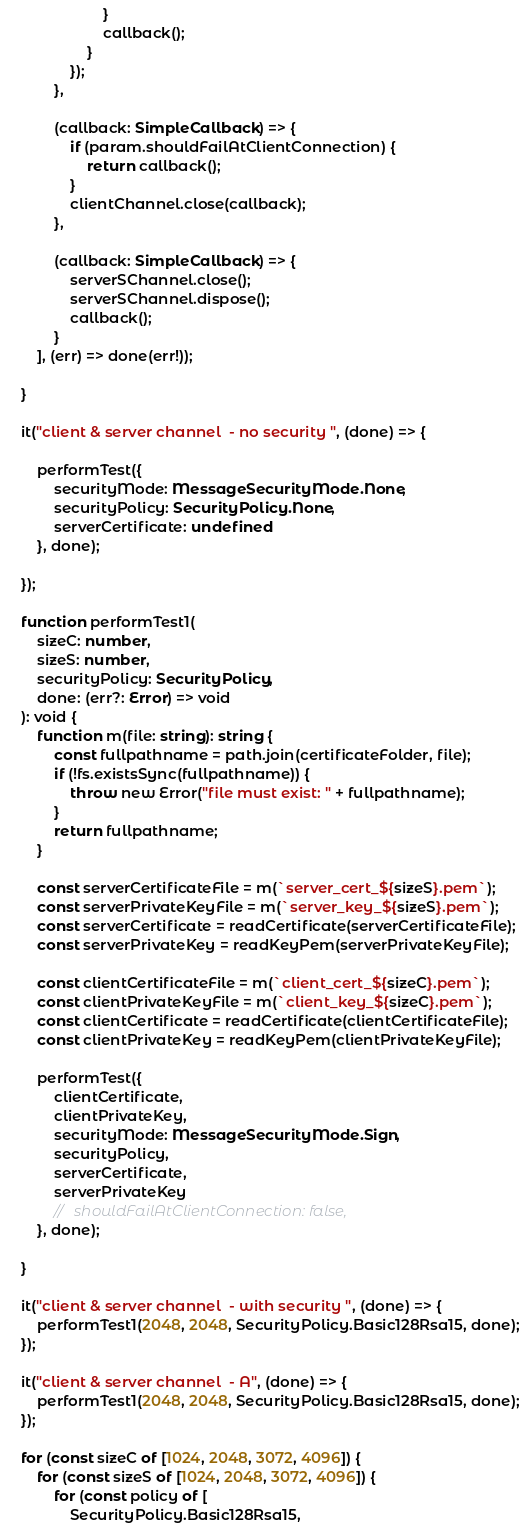Convert code to text. <code><loc_0><loc_0><loc_500><loc_500><_TypeScript_>                        }
                        callback();
                    }
                });
            },

            (callback: SimpleCallback) => {
                if (param.shouldFailAtClientConnection) {
                    return callback();
                }
                clientChannel.close(callback);
            },

            (callback: SimpleCallback) => {
                serverSChannel.close();
                serverSChannel.dispose();
                callback();
            }
        ], (err) => done(err!));

    }

    it("client & server channel  - no security ", (done) => {

        performTest({
            securityMode: MessageSecurityMode.None,
            securityPolicy: SecurityPolicy.None,
            serverCertificate: undefined
        }, done);

    });

    function performTest1(
        sizeC: number,
        sizeS: number,
        securityPolicy: SecurityPolicy,
        done: (err?: Error) => void
    ): void {
        function m(file: string): string {
            const fullpathname = path.join(certificateFolder, file);
            if (!fs.existsSync(fullpathname)) {
                throw new Error("file must exist: " + fullpathname);
            }
            return fullpathname;
        }

        const serverCertificateFile = m(`server_cert_${sizeS}.pem`);
        const serverPrivateKeyFile = m(`server_key_${sizeS}.pem`);
        const serverCertificate = readCertificate(serverCertificateFile);
        const serverPrivateKey = readKeyPem(serverPrivateKeyFile);

        const clientCertificateFile = m(`client_cert_${sizeC}.pem`);
        const clientPrivateKeyFile = m(`client_key_${sizeC}.pem`);
        const clientCertificate = readCertificate(clientCertificateFile);
        const clientPrivateKey = readKeyPem(clientPrivateKeyFile);

        performTest({
            clientCertificate,
            clientPrivateKey,
            securityMode: MessageSecurityMode.Sign,
            securityPolicy,
            serverCertificate,
            serverPrivateKey
            //   shouldFailAtClientConnection: false,
        }, done);

    }

    it("client & server channel  - with security ", (done) => {
        performTest1(2048, 2048, SecurityPolicy.Basic128Rsa15, done);
    });

    it("client & server channel  - A", (done) => {
        performTest1(2048, 2048, SecurityPolicy.Basic128Rsa15, done);
    });

    for (const sizeC of [1024, 2048, 3072, 4096]) {
        for (const sizeS of [1024, 2048, 3072, 4096]) {
            for (const policy of [
                SecurityPolicy.Basic128Rsa15,</code> 